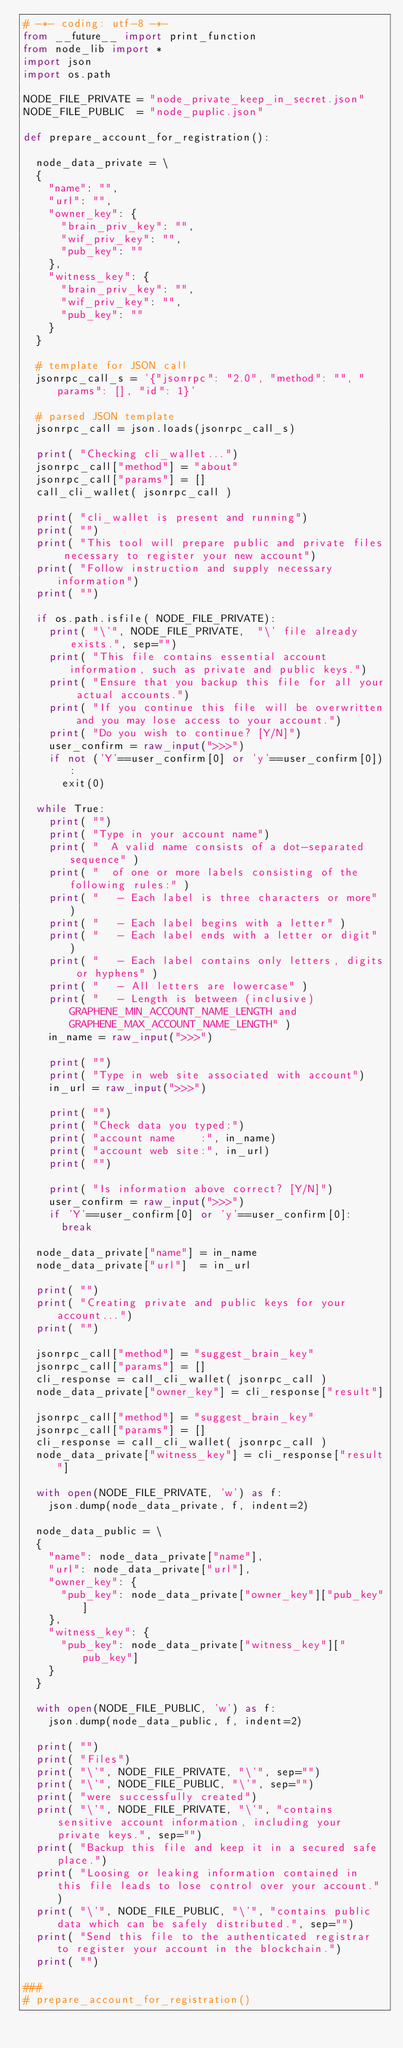Convert code to text. <code><loc_0><loc_0><loc_500><loc_500><_Python_># -*- coding: utf-8 -*-
from __future__ import print_function
from node_lib import *
import json
import os.path

NODE_FILE_PRIVATE = "node_private_keep_in_secret.json"
NODE_FILE_PUBLIC  = "node_puplic.json"

def prepare_account_for_registration():

  node_data_private = \
  {
    "name": "",
    "url": "",
    "owner_key": {
      "brain_priv_key": "",
      "wif_priv_key": "",
      "pub_key": ""
    },
    "witness_key": {
      "brain_priv_key": "",
      "wif_priv_key": "",
      "pub_key": ""
    }
  }

  # template for JSON call
  jsonrpc_call_s = '{"jsonrpc": "2.0", "method": "", "params": [], "id": 1}'

  # parsed JSON template
  jsonrpc_call = json.loads(jsonrpc_call_s)

  print( "Checking cli_wallet...")
  jsonrpc_call["method"] = "about"
  jsonrpc_call["params"] = []
  call_cli_wallet( jsonrpc_call )

  print( "cli_wallet is present and running")
  print( "")
  print( "This tool will prepare public and private files necessary to register your new account")
  print( "Follow instruction and supply necessary information")
  print( "")

  if os.path.isfile( NODE_FILE_PRIVATE):
    print( "\'", NODE_FILE_PRIVATE,  "\' file already exists.", sep="")
    print( "This file contains essential account information, such as private and public keys.")
    print( "Ensure that you backup this file for all your actual accounts.")
    print( "If you continue this file will be overwritten and you may lose access to your account.")
    print( "Do you wish to continue? [Y/N]")
    user_confirm = raw_input(">>>")
    if not ('Y'==user_confirm[0] or 'y'==user_confirm[0]):
      exit(0)

  while True:
    print( "")
    print( "Type in your account name")
    print( "  A valid name consists of a dot-separated sequence" )
    print( "  of one or more labels consisting of the following rules:" )
    print( "   - Each label is three characters or more" )
    print( "   - Each label begins with a letter" )
    print( "   - Each label ends with a letter or digit" )
    print( "   - Each label contains only letters, digits or hyphens" )
    print( "   - All letters are lowercase" )
    print( "   - Length is between (inclusive) GRAPHENE_MIN_ACCOUNT_NAME_LENGTH and GRAPHENE_MAX_ACCOUNT_NAME_LENGTH" )
    in_name = raw_input(">>>")

    print( "")
    print( "Type in web site associated with account")
    in_url = raw_input(">>>")

    print( "")
    print( "Check data you typed:")
    print( "account name    :", in_name)
    print( "account web site:", in_url)
    print( "")

    print( "Is information above correct? [Y/N]")
    user_confirm = raw_input(">>>")
    if 'Y'==user_confirm[0] or 'y'==user_confirm[0]:
      break

  node_data_private["name"] = in_name
  node_data_private["url"]  = in_url

  print( "")
  print( "Creating private and public keys for your account...")
  print( "")

  jsonrpc_call["method"] = "suggest_brain_key"
  jsonrpc_call["params"] = []
  cli_response = call_cli_wallet( jsonrpc_call )
  node_data_private["owner_key"] = cli_response["result"]

  jsonrpc_call["method"] = "suggest_brain_key"
  jsonrpc_call["params"] = []
  cli_response = call_cli_wallet( jsonrpc_call )
  node_data_private["witness_key"] = cli_response["result"]

  with open(NODE_FILE_PRIVATE, 'w') as f:
    json.dump(node_data_private, f, indent=2)

  node_data_public = \
  {
    "name": node_data_private["name"],
    "url": node_data_private["url"],
    "owner_key": {
      "pub_key": node_data_private["owner_key"]["pub_key"]
    },
    "witness_key": {
      "pub_key": node_data_private["witness_key"]["pub_key"]
    }
  }

  with open(NODE_FILE_PUBLIC, 'w') as f:
    json.dump(node_data_public, f, indent=2)

  print( "")
  print( "Files")
  print( "\'", NODE_FILE_PRIVATE, "\'", sep="")
  print( "\'", NODE_FILE_PUBLIC, "\'", sep="")
  print( "were successfully created")
  print( "\'", NODE_FILE_PRIVATE, "\'", "contains sensitive account information, including your private keys.", sep="")
  print( "Backup this file and keep it in a secured safe place.")
  print( "Loosing or leaking information contained in this file leads to lose control over your account." )
  print( "\'", NODE_FILE_PUBLIC, "\'", "contains public data which can be safely distributed.", sep="")
  print( "Send this file to the authenticated registrar to register your account in the blockchain.")
  print( "")

###
# prepare_account_for_registration()

  



</code> 